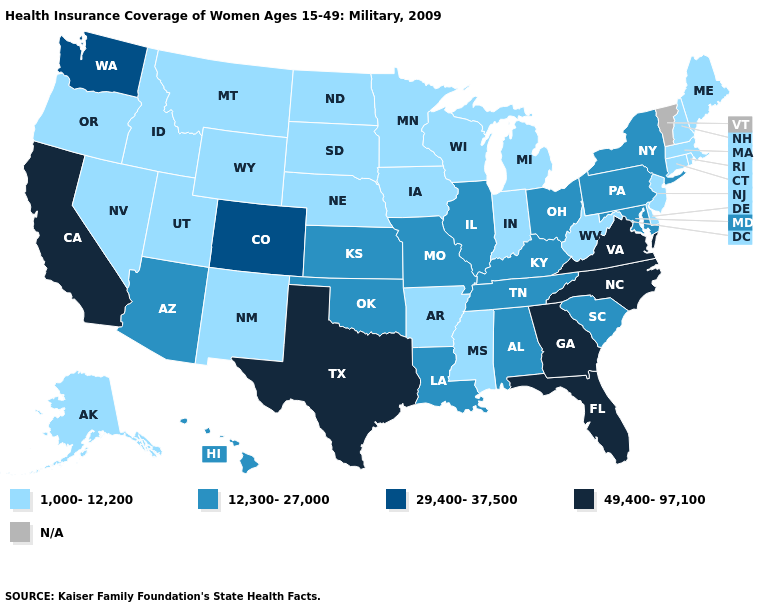What is the lowest value in states that border Indiana?
Be succinct. 1,000-12,200. What is the value of Oklahoma?
Give a very brief answer. 12,300-27,000. Does Colorado have the highest value in the USA?
Keep it brief. No. What is the value of Oklahoma?
Concise answer only. 12,300-27,000. Name the states that have a value in the range 29,400-37,500?
Give a very brief answer. Colorado, Washington. Name the states that have a value in the range 49,400-97,100?
Write a very short answer. California, Florida, Georgia, North Carolina, Texas, Virginia. Name the states that have a value in the range 1,000-12,200?
Be succinct. Alaska, Arkansas, Connecticut, Delaware, Idaho, Indiana, Iowa, Maine, Massachusetts, Michigan, Minnesota, Mississippi, Montana, Nebraska, Nevada, New Hampshire, New Jersey, New Mexico, North Dakota, Oregon, Rhode Island, South Dakota, Utah, West Virginia, Wisconsin, Wyoming. What is the highest value in the USA?
Concise answer only. 49,400-97,100. What is the value of New Jersey?
Give a very brief answer. 1,000-12,200. Name the states that have a value in the range 49,400-97,100?
Give a very brief answer. California, Florida, Georgia, North Carolina, Texas, Virginia. What is the highest value in states that border Arizona?
Short answer required. 49,400-97,100. Name the states that have a value in the range 29,400-37,500?
Be succinct. Colorado, Washington. What is the value of Wisconsin?
Short answer required. 1,000-12,200. 